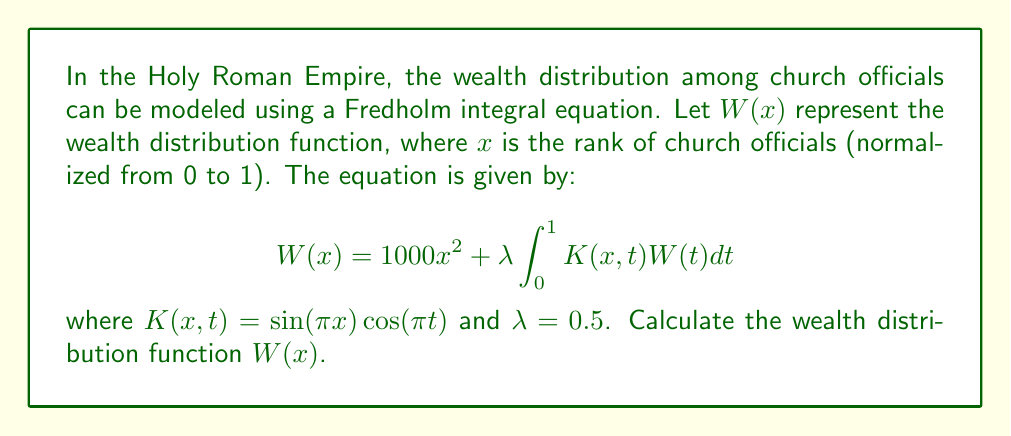Give your solution to this math problem. To solve this Fredholm integral equation, we'll use the method of successive approximations:

1) Start with an initial guess: $W_0(x) = 1000x^2$

2) Substitute this into the right-hand side of the equation to get the next approximation:

   $W_1(x) = 1000x^2 + 0.5 \int_0^1 \sin(\pi x)\cos(\pi t)(1000t^2)dt$

3) Evaluate the integral:
   
   $\int_0^1 \cos(\pi t)t^2 dt = \frac{4}{\pi^3}$

4) Therefore:

   $W_1(x) = 1000x^2 + 1000 \cdot 0.5 \cdot \frac{4}{\pi^3} \sin(\pi x)$

5) For the next iteration:

   $W_2(x) = 1000x^2 + 0.5 \int_0^1 \sin(\pi x)\cos(\pi t)(1000t^2 + 1000 \cdot 0.5 \cdot \frac{4}{\pi^3} \sin(\pi t))dt$

6) Evaluate this integral:

   $W_2(x) = 1000x^2 + 1000 \cdot 0.5 \cdot \frac{4}{\pi^3} \sin(\pi x) + 0$

7) We see that $W_2(x) = W_1(x)$, so we've reached the solution.
Answer: $W(x) = 1000x^2 + \frac{2000}{\pi^3} \sin(\pi x)$ 